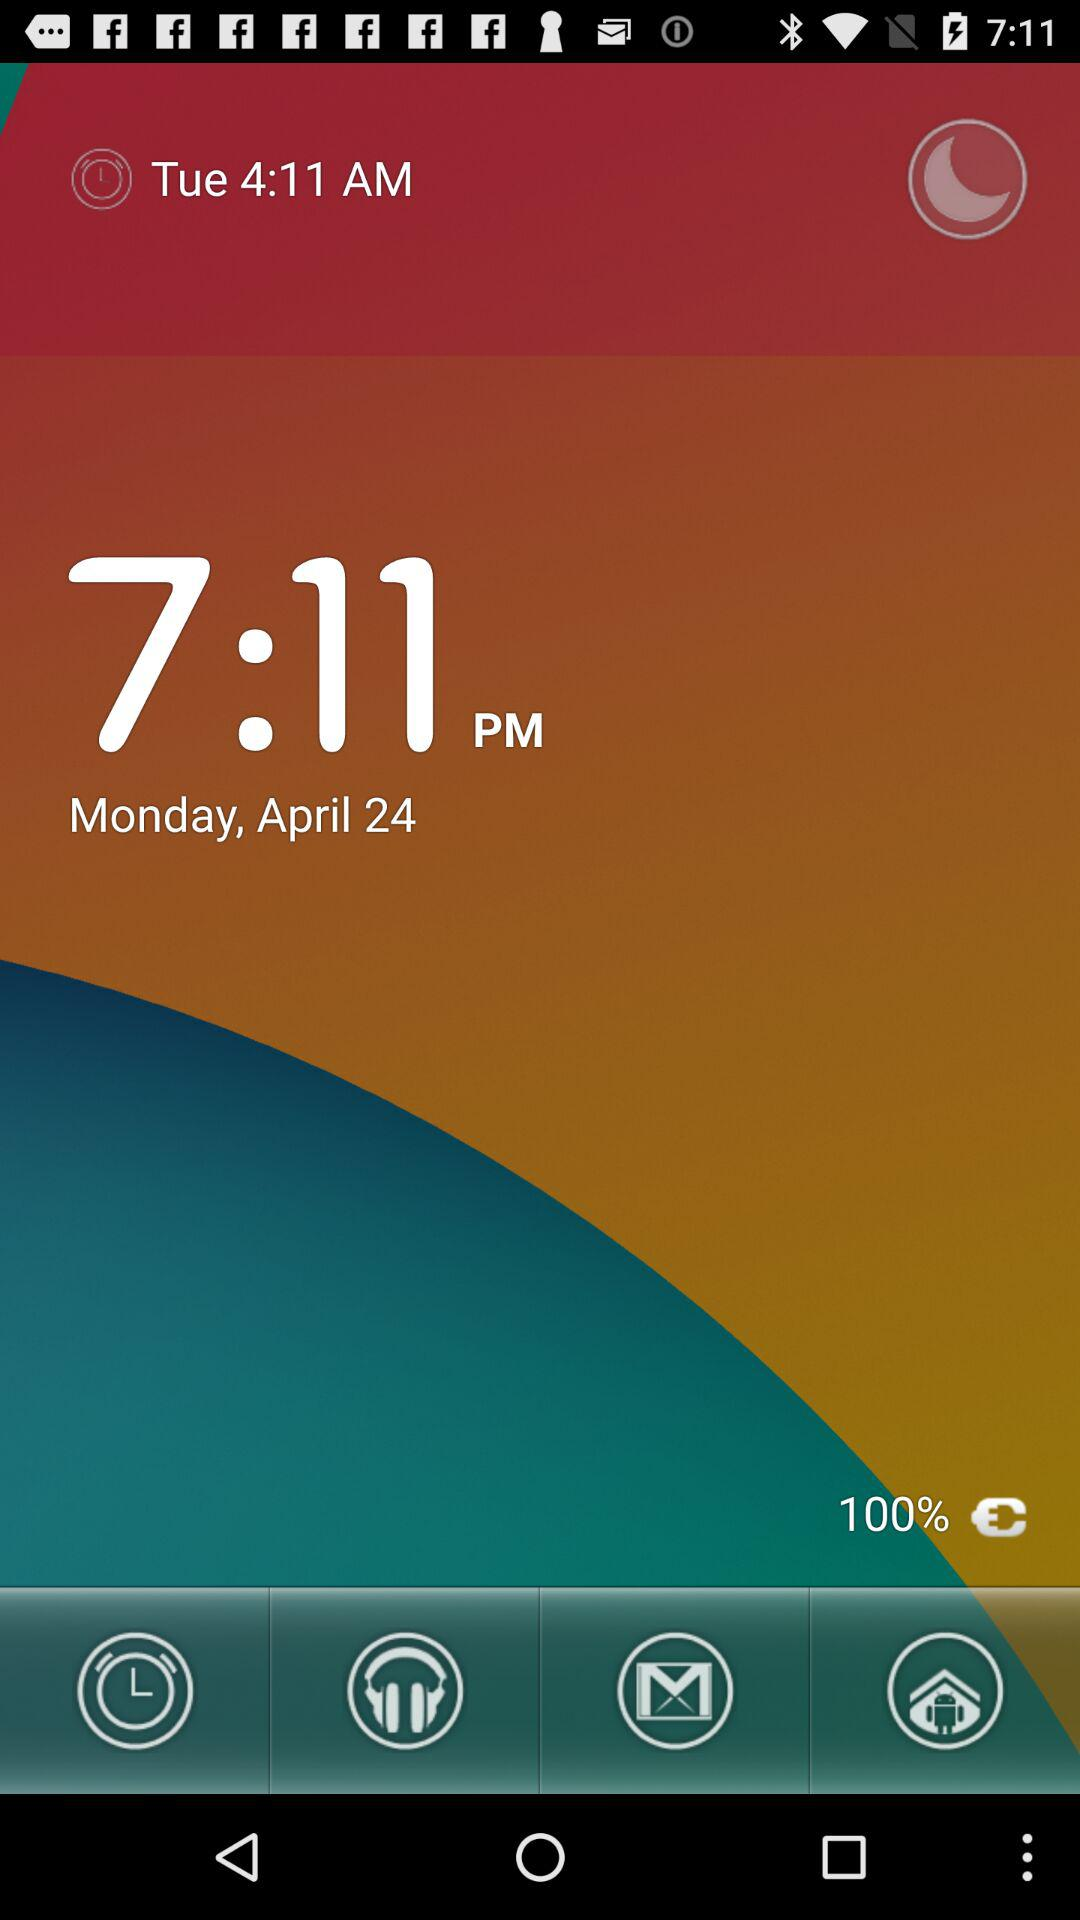What time is the alarm set for? The alarm is set for 4:11 AM. 